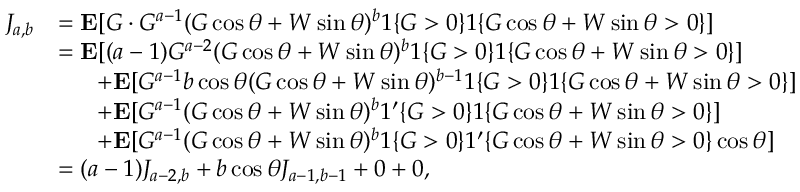<formula> <loc_0><loc_0><loc_500><loc_500>\begin{array} { r l } { J _ { a , b } } & { = E [ G \cdot G ^ { a - 1 } ( G \cos \theta + W \sin \theta ) ^ { b } 1 \{ G > 0 \} 1 \{ G \cos \theta + W \sin \theta > 0 \} ] } \\ & { = E [ ( a - 1 ) G ^ { a - 2 } ( G \cos \theta + W \sin \theta ) ^ { b } 1 \{ G > 0 \} 1 \{ G \cos \theta + W \sin \theta > 0 \} ] } \\ & { \, + E [ G ^ { a - 1 } b \cos \theta ( G \cos \theta + W \sin \theta ) ^ { b - 1 } 1 \{ G > 0 \} 1 \{ G \cos \theta + W \sin \theta > 0 \} ] } \\ & { \, + E [ G ^ { a - 1 } ( G \cos \theta + W \sin \theta ) ^ { b } 1 ^ { \prime } \{ G > 0 \} 1 \{ G \cos \theta + W \sin \theta > 0 \} ] } \\ & { \, + E [ G ^ { a - 1 } ( G \cos \theta + W \sin \theta ) ^ { b } 1 \{ G > 0 \} 1 ^ { \prime } \{ G \cos \theta + W \sin \theta > 0 \} \cos \theta ] } \\ & { = ( a - 1 ) J _ { a - 2 , b } + b \cos \theta J _ { a - 1 , b - 1 } + 0 + 0 , } \end{array}</formula> 